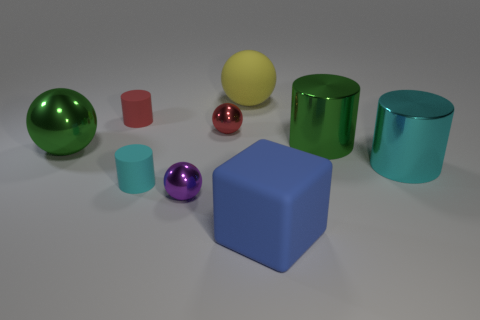Subtract 1 balls. How many balls are left? 3 Subtract all yellow spheres. Subtract all cyan cylinders. How many spheres are left? 3 Add 1 red metal spheres. How many objects exist? 10 Subtract all cubes. How many objects are left? 8 Add 2 small metallic objects. How many small metallic objects exist? 4 Subtract 1 cyan cylinders. How many objects are left? 8 Subtract all large cyan objects. Subtract all tiny red metal balls. How many objects are left? 7 Add 1 blue things. How many blue things are left? 2 